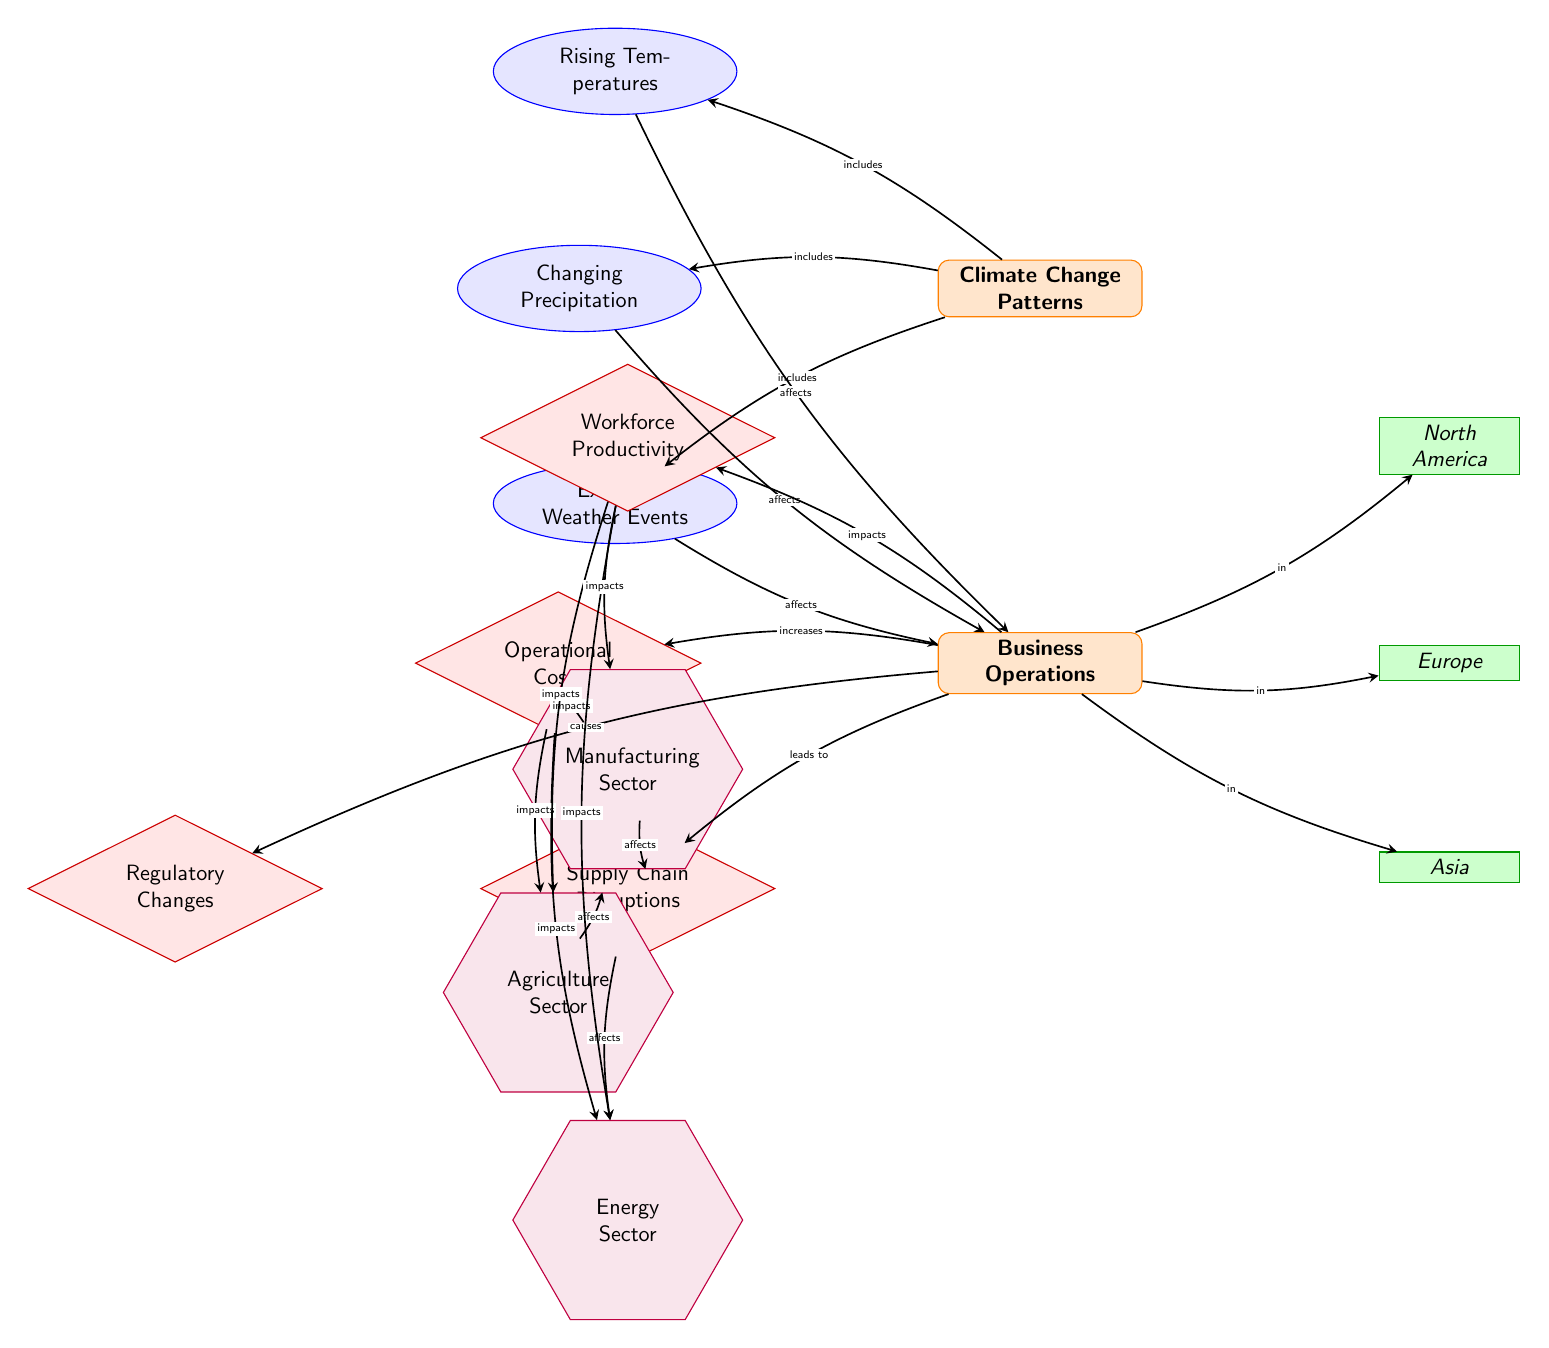What are the three climate change patterns listed in the diagram? The diagram identifies three climate change patterns as nodes: Rising Temperatures, Changing Precipitation, and Extreme Weather Events. These can be found positioned above the 'Climate Change Patterns' topic node.
Answer: Rising Temperatures, Changing Precipitation, Extreme Weather Events Which region is connected to 'Business Operations' in the diagram? The diagram shows three regions connected to 'Business Operations': North America, Europe, and Asia. Each of these regions is represented as a node positioned to the right of 'Business Operations'.
Answer: North America, Europe, Asia What impact is listed as a consequence of 'Business Operations'? The diagram indicates four key impacts stemming from 'Business Operations': Supply Chain Disruptions, Operational Costs, Workforce Productivity, and Regulatory Changes. These impacts are represented as nodes branching down from 'Business Operations'.
Answer: Supply Chain Disruptions, Operational Costs, Workforce Productivity, Regulatory Changes How many industries are affected by supply chain disruptions? The diagram shows three industries affected by Supply Chain Disruptions: Energy Sector, Agriculture Sector, and Manufacturing Sector. Each of these industries is connected to the Supply Chain Disruptions node with directional edges.
Answer: 3 What does changing precipitation affect according to the diagram? The diagram illustrates that Changing Precipitation affects Business Operations, as indicated by a directed edge from Changing Precipitation to Business Operations. This reasoning suggests that the impact of changing precipitation directly influences general business practices.
Answer: Business Operations Which climate pattern affects workforce productivity? The diagram explicitly connects Rising Temperatures, Changing Precipitation, and Extreme Weather Events to Workforce Productivity, as indicated by directional edges from these climate patterns to the Workforce Productivity node. Thus, all three patterns penetrate into Workforce Productivity.
Answer: Rising Temperatures, Changing Precipitation, Extreme Weather Events What is the direct relationship between extreme weather events and business operations? According to the diagram, extreme weather events have a direct effect on Business Operations, as shown by the edge leading from the node Extreme Weather Events to the node Business Operations. This signifies that extreme weather events indeed influence how businesses operate.
Answer: Affects Which pattern involves rising temperatures and what is its influence? The diagram reveals that Rising Temperatures influence Business Operations, indicated by a flow from the Rising Temperatures node to the Business Operations node. Thus, rising temperatures are explicitly connected to the impact on businesses.
Answer: Business Operations 